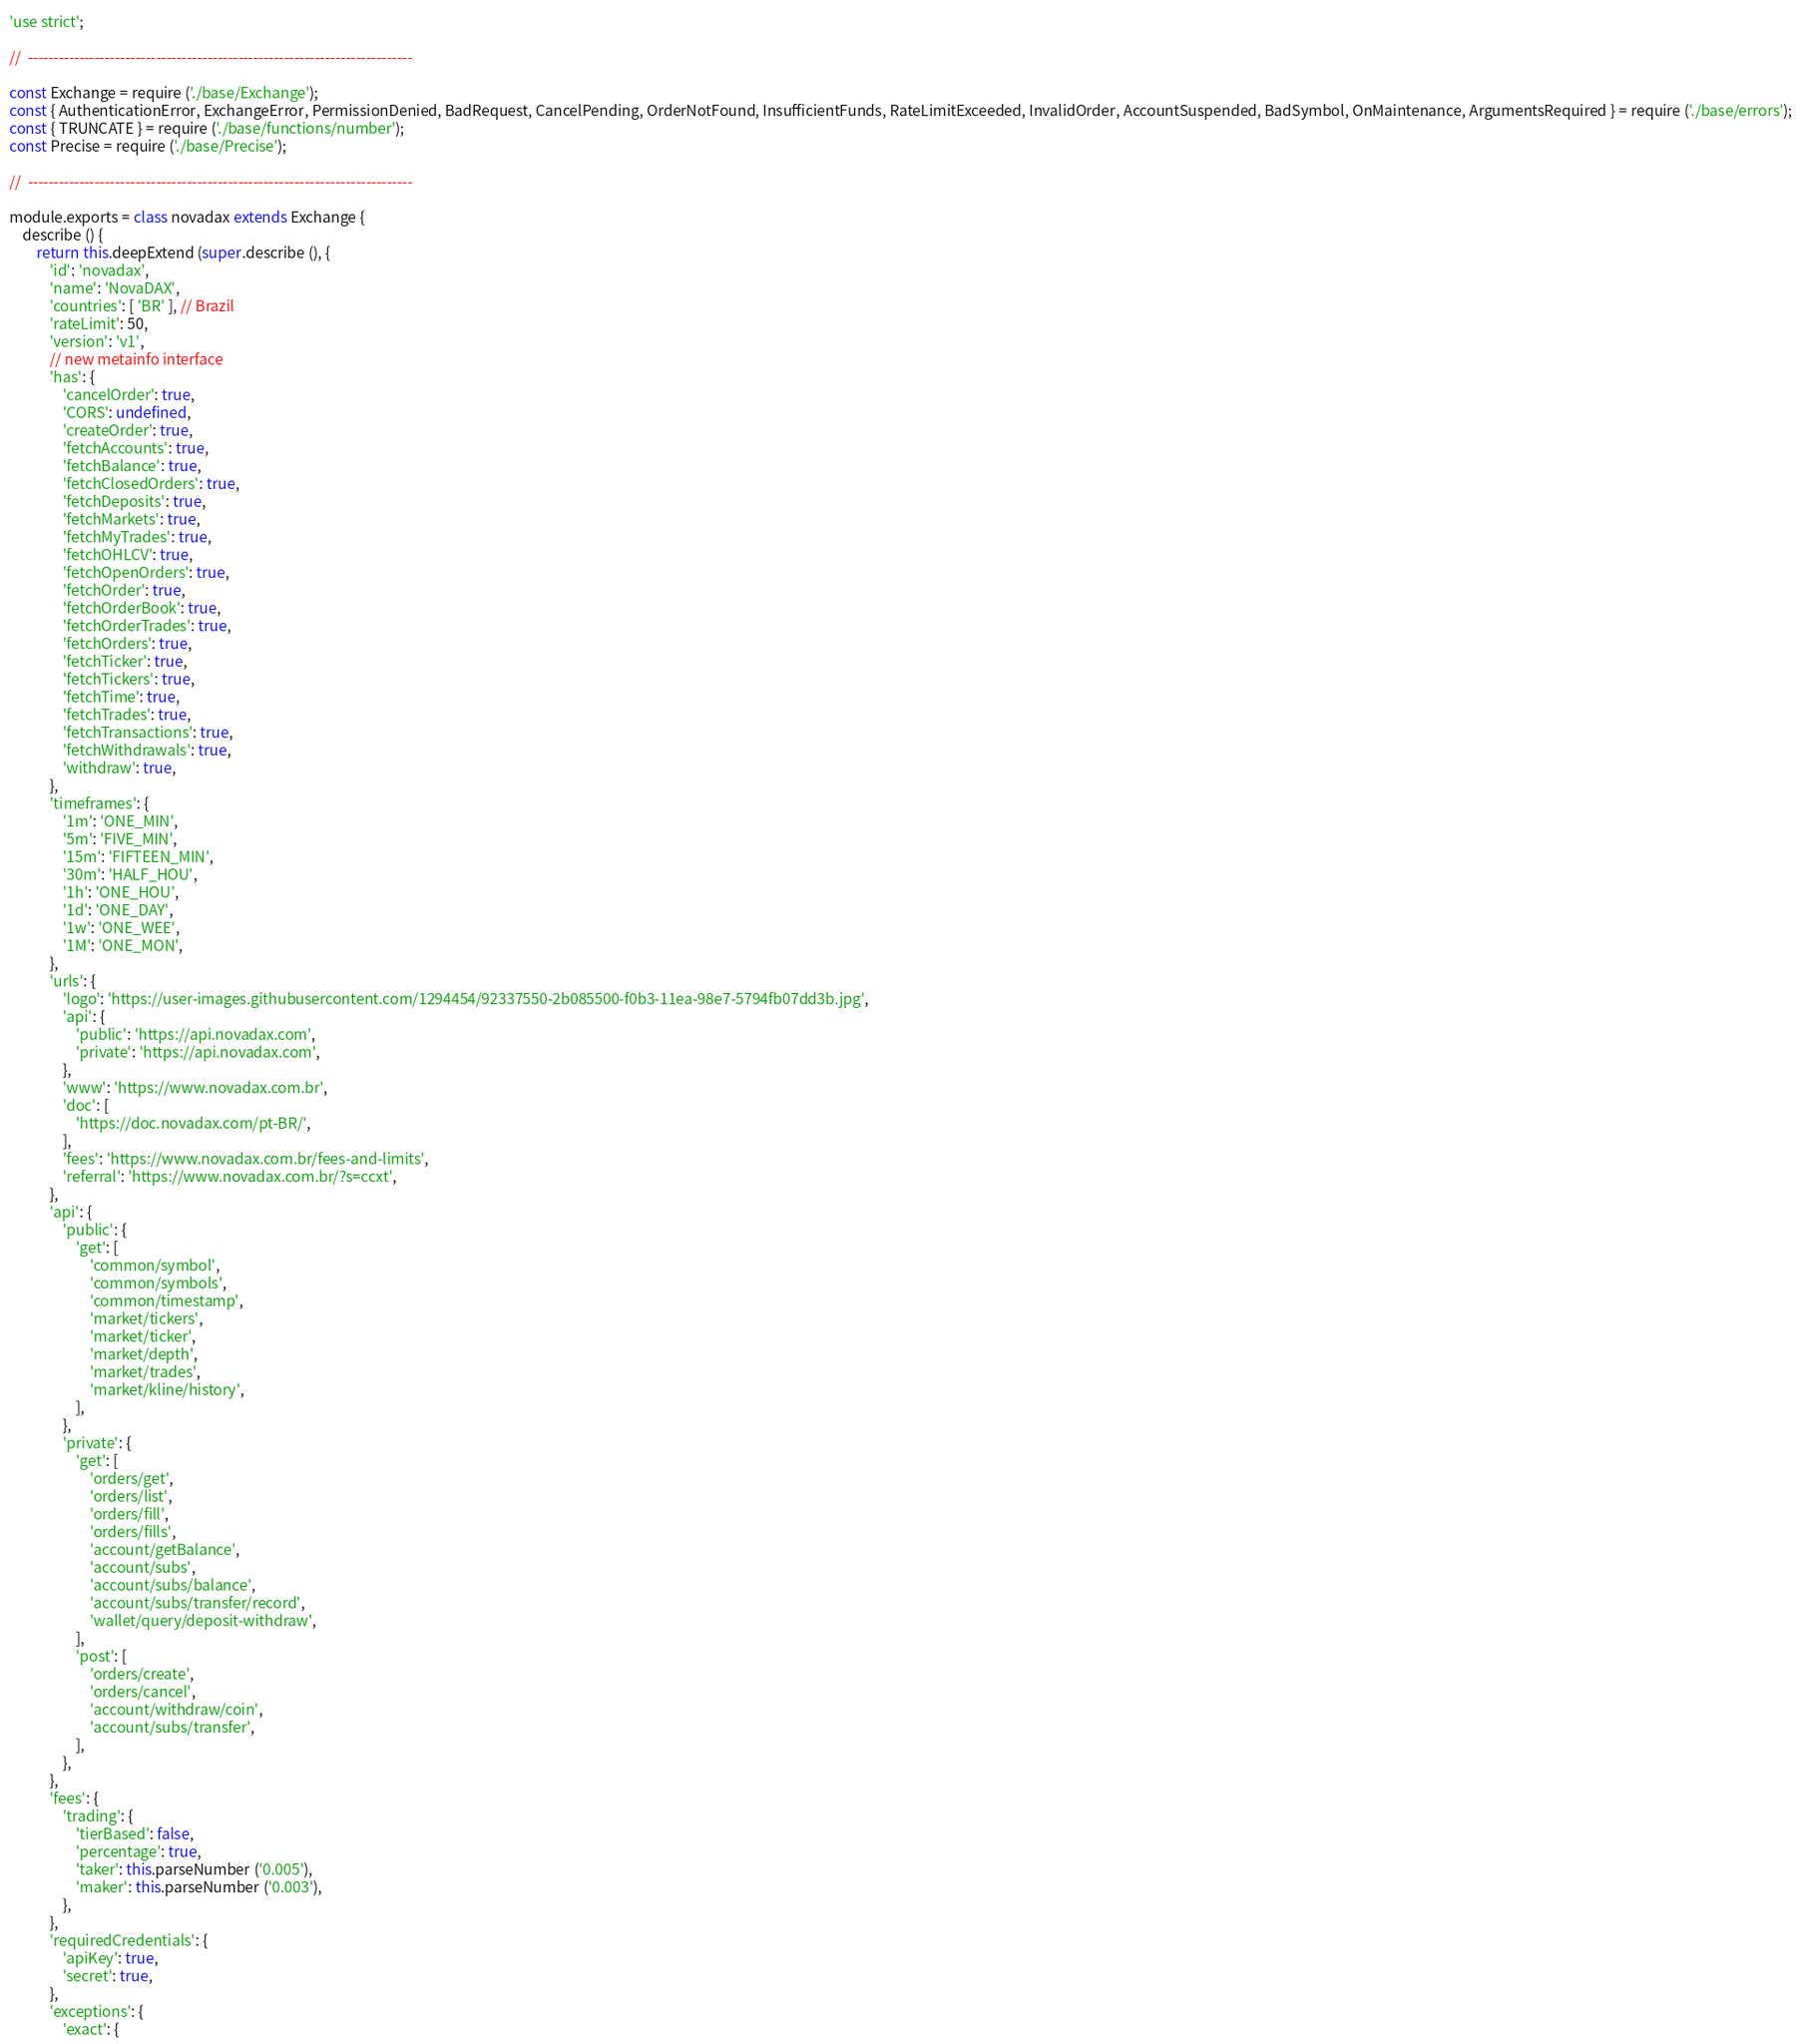Convert code to text. <code><loc_0><loc_0><loc_500><loc_500><_JavaScript_>'use strict';

//  ---------------------------------------------------------------------------

const Exchange = require ('./base/Exchange');
const { AuthenticationError, ExchangeError, PermissionDenied, BadRequest, CancelPending, OrderNotFound, InsufficientFunds, RateLimitExceeded, InvalidOrder, AccountSuspended, BadSymbol, OnMaintenance, ArgumentsRequired } = require ('./base/errors');
const { TRUNCATE } = require ('./base/functions/number');
const Precise = require ('./base/Precise');

//  ---------------------------------------------------------------------------

module.exports = class novadax extends Exchange {
    describe () {
        return this.deepExtend (super.describe (), {
            'id': 'novadax',
            'name': 'NovaDAX',
            'countries': [ 'BR' ], // Brazil
            'rateLimit': 50,
            'version': 'v1',
            // new metainfo interface
            'has': {
                'cancelOrder': true,
                'CORS': undefined,
                'createOrder': true,
                'fetchAccounts': true,
                'fetchBalance': true,
                'fetchClosedOrders': true,
                'fetchDeposits': true,
                'fetchMarkets': true,
                'fetchMyTrades': true,
                'fetchOHLCV': true,
                'fetchOpenOrders': true,
                'fetchOrder': true,
                'fetchOrderBook': true,
                'fetchOrderTrades': true,
                'fetchOrders': true,
                'fetchTicker': true,
                'fetchTickers': true,
                'fetchTime': true,
                'fetchTrades': true,
                'fetchTransactions': true,
                'fetchWithdrawals': true,
                'withdraw': true,
            },
            'timeframes': {
                '1m': 'ONE_MIN',
                '5m': 'FIVE_MIN',
                '15m': 'FIFTEEN_MIN',
                '30m': 'HALF_HOU',
                '1h': 'ONE_HOU',
                '1d': 'ONE_DAY',
                '1w': 'ONE_WEE',
                '1M': 'ONE_MON',
            },
            'urls': {
                'logo': 'https://user-images.githubusercontent.com/1294454/92337550-2b085500-f0b3-11ea-98e7-5794fb07dd3b.jpg',
                'api': {
                    'public': 'https://api.novadax.com',
                    'private': 'https://api.novadax.com',
                },
                'www': 'https://www.novadax.com.br',
                'doc': [
                    'https://doc.novadax.com/pt-BR/',
                ],
                'fees': 'https://www.novadax.com.br/fees-and-limits',
                'referral': 'https://www.novadax.com.br/?s=ccxt',
            },
            'api': {
                'public': {
                    'get': [
                        'common/symbol',
                        'common/symbols',
                        'common/timestamp',
                        'market/tickers',
                        'market/ticker',
                        'market/depth',
                        'market/trades',
                        'market/kline/history',
                    ],
                },
                'private': {
                    'get': [
                        'orders/get',
                        'orders/list',
                        'orders/fill',
                        'orders/fills',
                        'account/getBalance',
                        'account/subs',
                        'account/subs/balance',
                        'account/subs/transfer/record',
                        'wallet/query/deposit-withdraw',
                    ],
                    'post': [
                        'orders/create',
                        'orders/cancel',
                        'account/withdraw/coin',
                        'account/subs/transfer',
                    ],
                },
            },
            'fees': {
                'trading': {
                    'tierBased': false,
                    'percentage': true,
                    'taker': this.parseNumber ('0.005'),
                    'maker': this.parseNumber ('0.003'),
                },
            },
            'requiredCredentials': {
                'apiKey': true,
                'secret': true,
            },
            'exceptions': {
                'exact': {</code> 